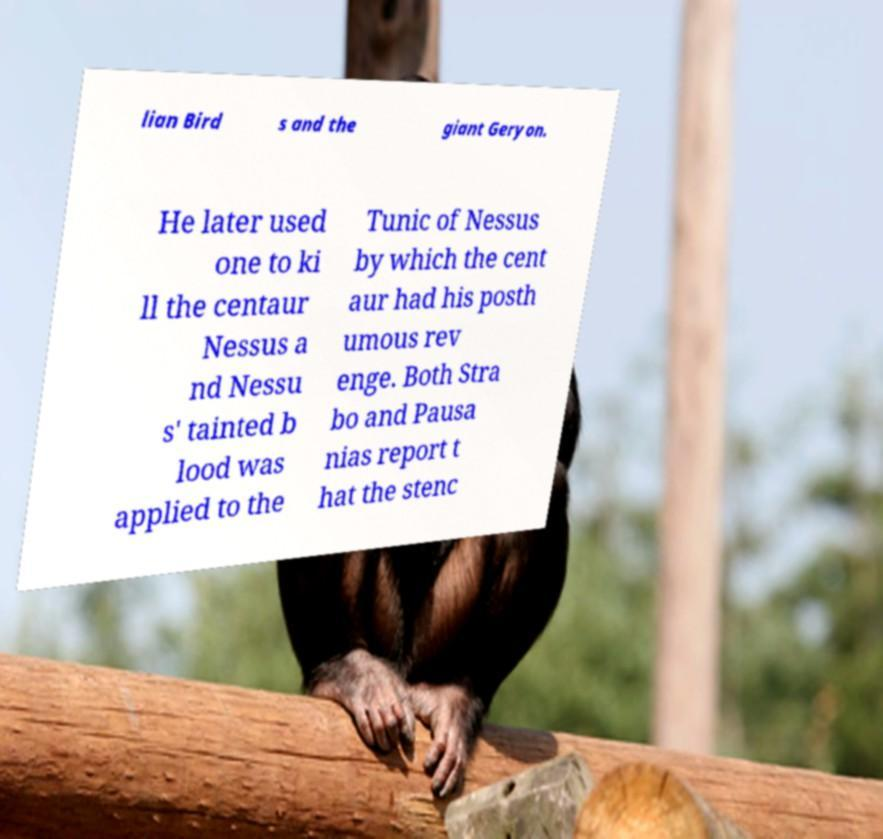Please identify and transcribe the text found in this image. lian Bird s and the giant Geryon. He later used one to ki ll the centaur Nessus a nd Nessu s' tainted b lood was applied to the Tunic of Nessus by which the cent aur had his posth umous rev enge. Both Stra bo and Pausa nias report t hat the stenc 